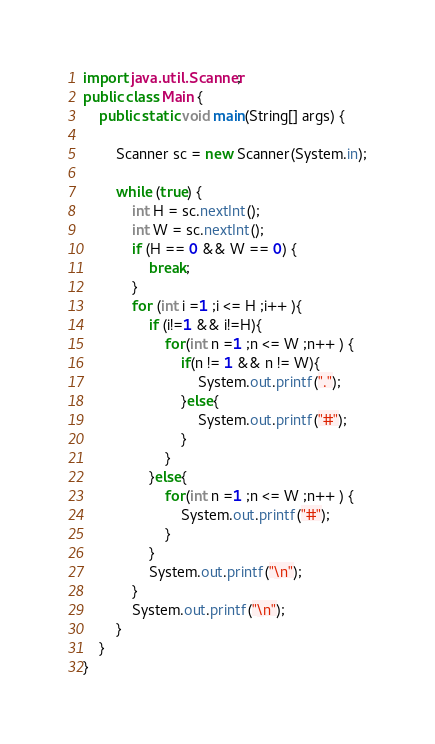<code> <loc_0><loc_0><loc_500><loc_500><_Java_>import java.util.Scanner;
public class Main {
    public static void main(String[] args) {

        Scanner sc = new Scanner(System.in);

        while (true) {
            int H = sc.nextInt();
            int W = sc.nextInt();
            if (H == 0 && W == 0) {
                break;
            }
            for (int i =1 ;i <= H ;i++ ){
                if (i!=1 && i!=H){
                    for(int n =1 ;n <= W ;n++ ) {
                        if(n != 1 && n != W){
                            System.out.printf(".");
                        }else{
                            System.out.printf("#");
                        }
                    }
                }else{
                    for(int n =1 ;n <= W ;n++ ) {
                        System.out.printf("#");
                    }
                }
                System.out.printf("\n");
            }
            System.out.printf("\n");
        }
    }
}</code> 